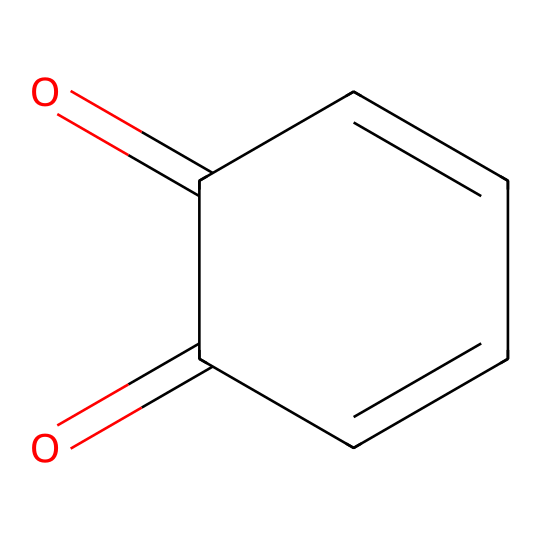What is the total number of carbon atoms in the structure? The SMILES representation indicates that there are five carbon atoms linked in a cyclic structure (C1=CC(=O)C(=O)C=C1). By counting each 'C' in the SMILES, we confirm the total.
Answer: five How many double bonds are present in this compound? The structure contains three double bonds, as identified by the presence of '=' signs in the SMILES representation. These are located between C1=C, C(=O), and C=C.
Answer: three What type of functional groups are present in the compound? The SMILES representation indicates the presence of two carbonyl groups (C=O) and a carbon-carbon double bond, confirming the functional groups.
Answer: carbonyl Does this compound exhibit hypervalency? Hypervalent compounds typically contain elements capable of expanding their octet beyond eight electrons. This compound has carbon atoms with four bonds (single and double), indicating that it does not exhibit hypervalency as characters indicate here.
Answer: no What is the maximum number of hydrogen atoms this compound can theoretically bond with? For saturated hydrocarbons with five carbons, the formula CnH(2n+2) predicts 12 hydrogen atoms. However, considering the double bonds and functional groups in the structure, the total count of hydrogen must be adjusted down to 6.
Answer: six 